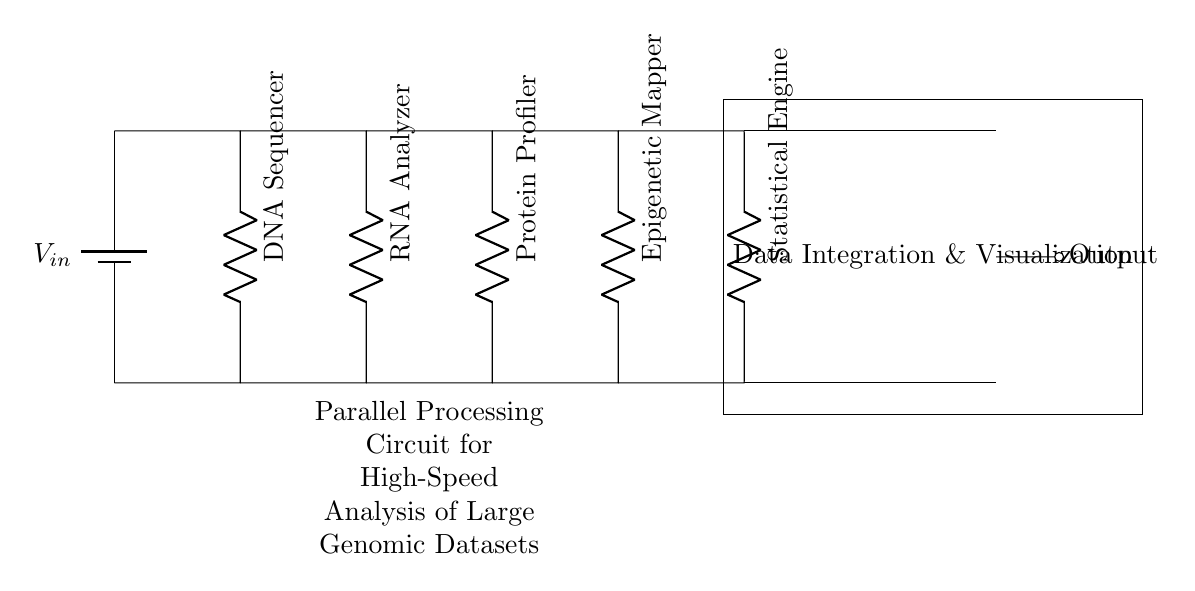What components are present in this circuit? The circuit contains a DNA sequencer, RNA analyzer, protein profiler, epigenetic mapper, and statistical engine, which are all resistors indicated by R labels.
Answer: DNA sequencer, RNA analyzer, protein profiler, epigenetic mapper, statistical engine What is the main purpose of the circuit? The circuit's main purpose is to optimize the processing of genomic datasets through parallel analysis, making it suitable for high-speed data evaluation. The label indicates its function.
Answer: High-speed analysis How many resistive components are in the circuit? There are five distinct resistive components, each representing a different analysis tool, as shown by the R labels separating them.
Answer: Five Which component handles DNA processing? The DNA sequencer is the component designated for DNA processing, as indicated in the diagram.
Answer: DNA sequencer What type of circuit is depicted? The circuit is a parallel processing circuit specifically laid out for simultaneous data analysis tasks in genomic research, as described in the title.
Answer: Parallel processing How are the components connected? The components are connected in parallel, allowing multiple data streams to be processed simultaneously, as indicated by the arrangement of the components in the diagram.
Answer: In parallel 